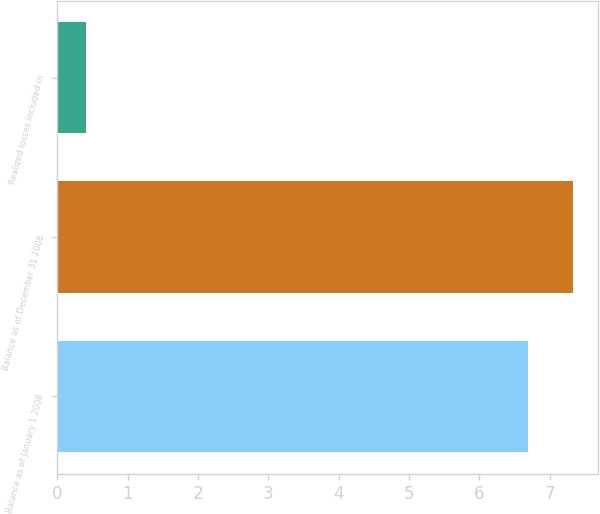Convert chart. <chart><loc_0><loc_0><loc_500><loc_500><bar_chart><fcel>Balance as of January 1 2008<fcel>Balance as of December 31 2008<fcel>Realized losses included in<nl><fcel>6.7<fcel>7.33<fcel>0.4<nl></chart> 